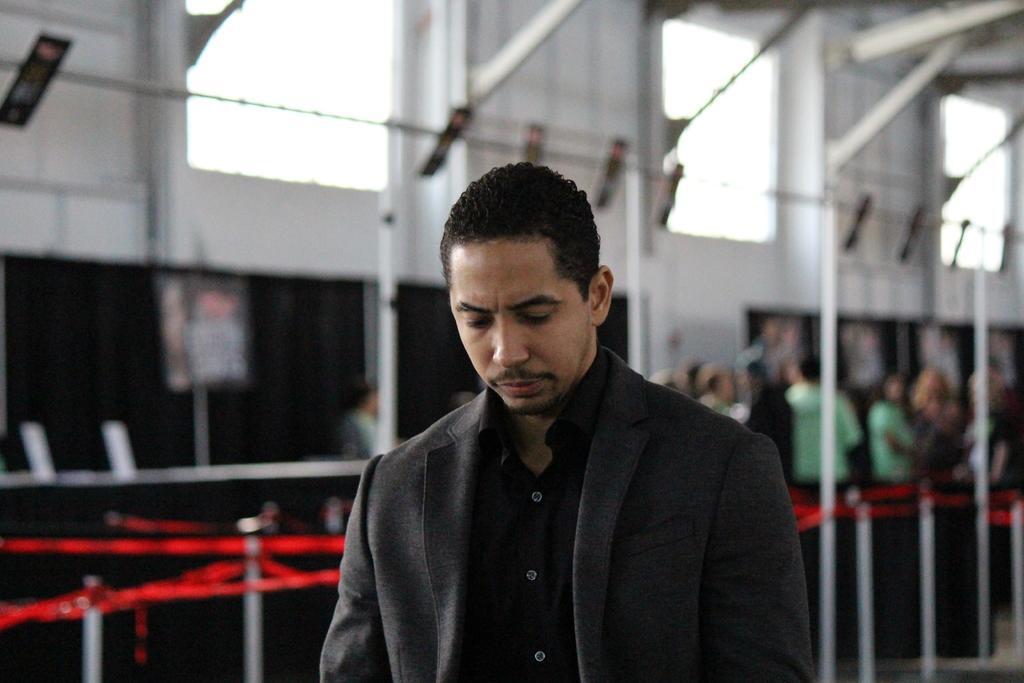In one or two sentences, can you explain what this image depicts? In this image we can see a man who is standing and he wear a suit. On back of him some people are standing in queue. This is the pole and we can see windows here. And this is the wall. 